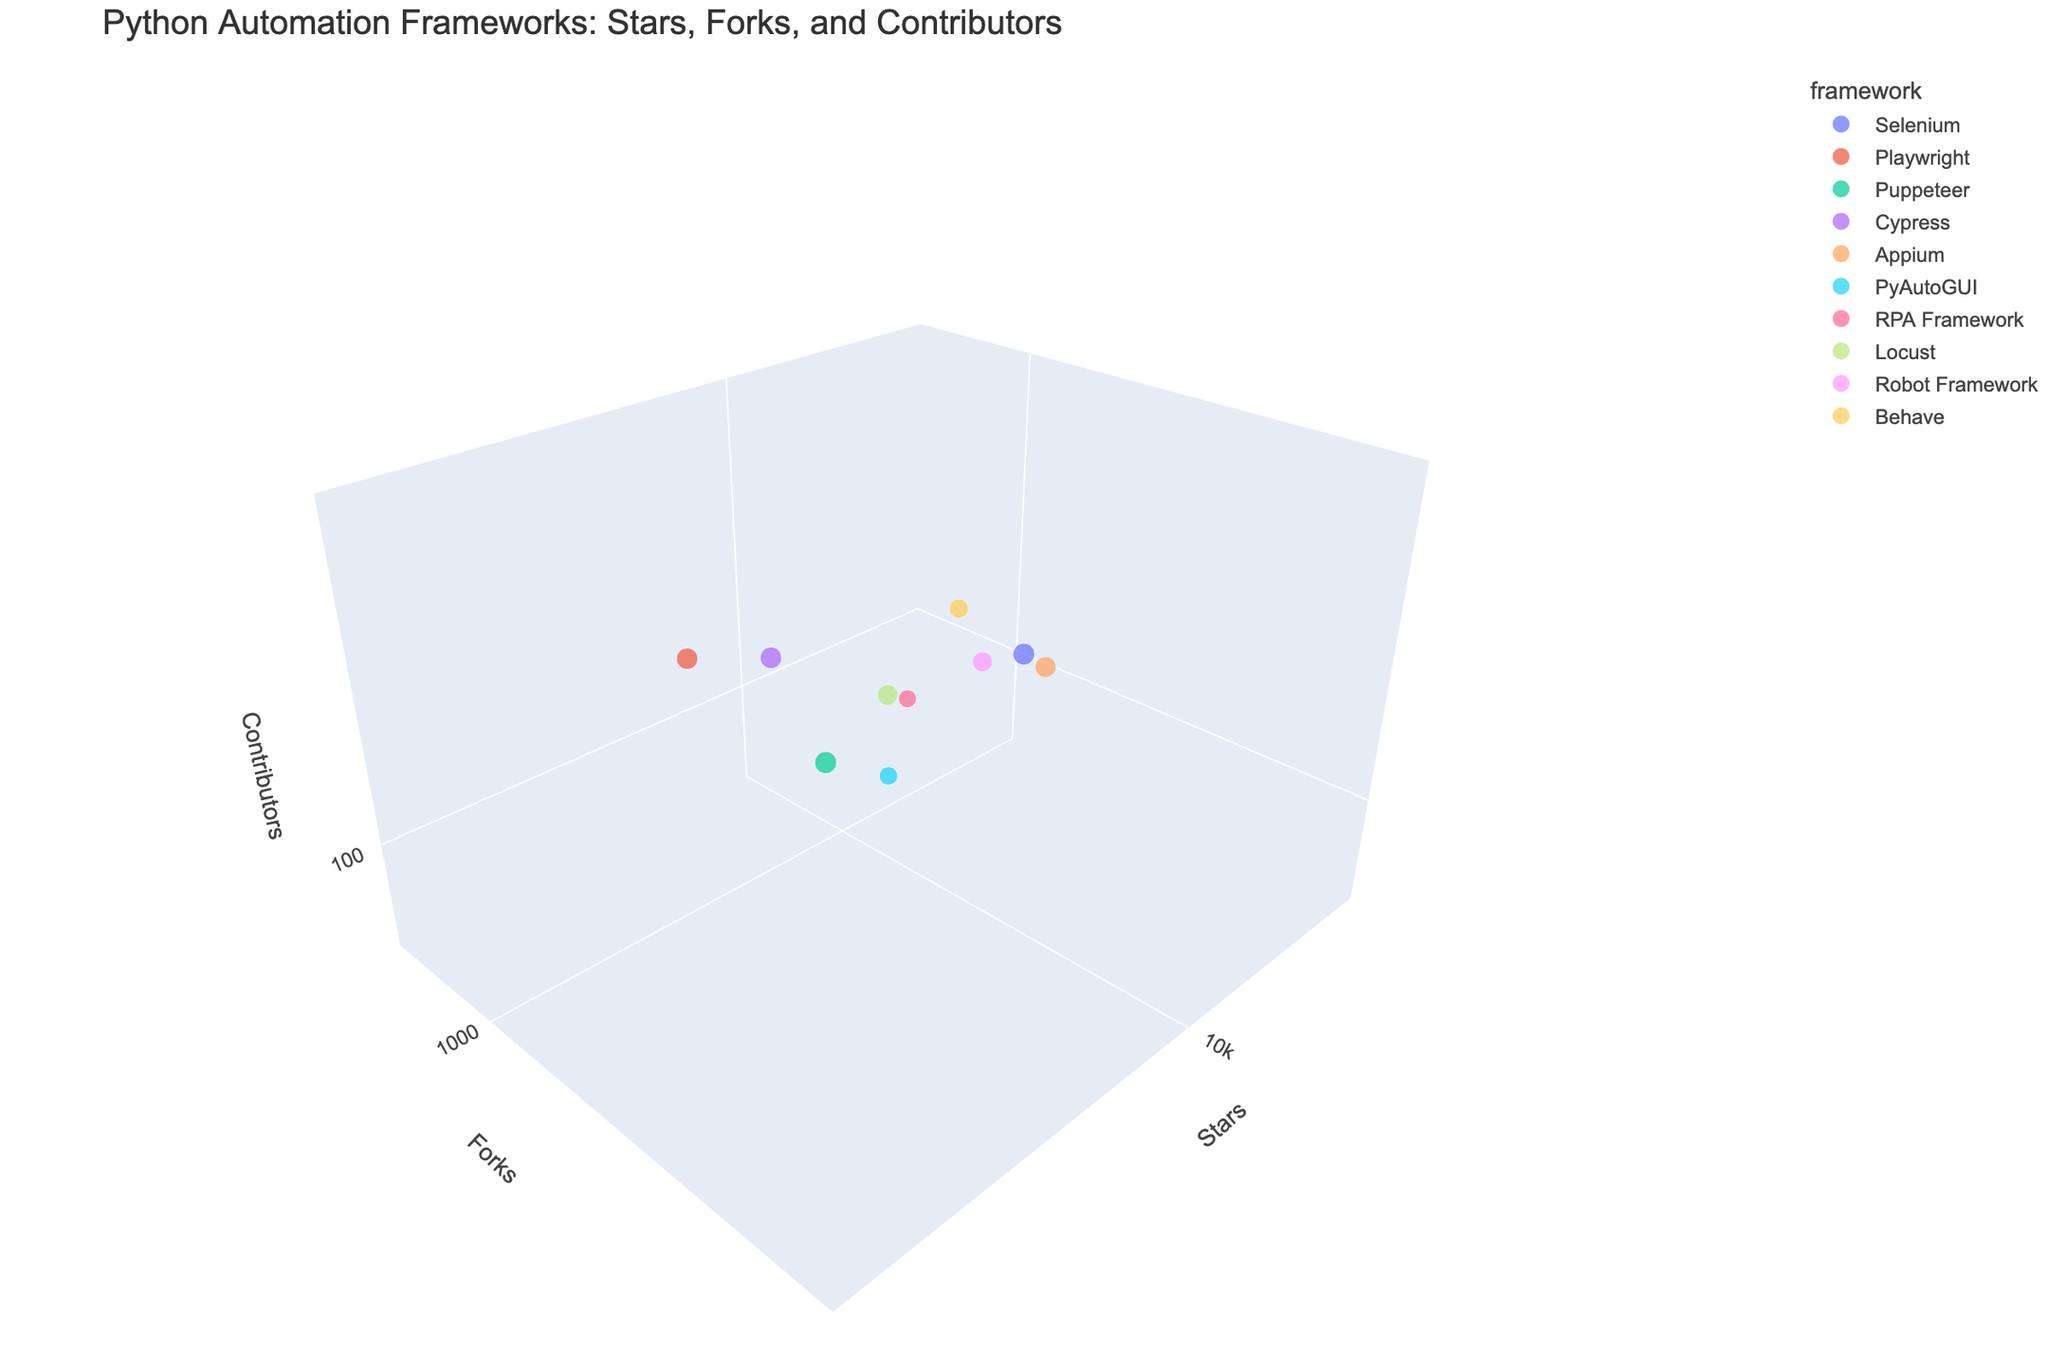Which framework has the highest number of stars? Look at the X-axis representing stars and find the bubble farthest to the right. Puppeteer is the framework with the highest stars.
Answer: Puppeteer Which framework has the lowest number of contributors? Look at the Z-axis representing contributors and find the bubble closest to the bottom. RPA Framework has the lowest number of contributors.
Answer: RPA Framework What is the approximate bubble size for the framework with the most forks? Find the bubble corresponding to the framework with the highest number of forks on the Y-axis. Puppeteer has the most forks with its bubble size reflecting approximately 20 * log(520).
Answer: Approximately 88 Are there any frameworks with more than 50,000 stars and more than 5,000 forks? Check for bubbles that are plotted beyond 50,000 on the X-axis and 5,000 on the Y-axis. Puppeteer is the only one meeting these criteria.
Answer: Yes, Puppeteer Which framework has more forks: Selenium or Cypress? Compare the Y-axis positions of the bubbles labeled Selenium and Cypress. Selenium with 6,800 forks has more than Cypress with 3,200 forks.
Answer: Selenium What is the total number of contributors for PyAutoGUI and Behave combined? Sum the contributors for PyAutoGUI (80) and Behave (120).
Answer: 200 How do the stars of Playwright compare to Appium? Compare the X-axis positions of the bubbles for Playwright and Appium. Playwright, with 48,000 stars, has significantly more stars than Appium, which has 15,000 stars.
Answer: Playwright has more Which framework is closest to having an equal number of stars and forks? Identify the bubble where the X-axis (stars) and Y-axis (forks) values are closest. Locust with 20,000 stars and 2,800 forks appears to have the closest values.
Answer: Locust What is the average number of contributors for Selenium, Playwright, and Cypress? Sum the contributors for Selenium (450), Playwright (380), and Cypress (410), then divide by 3. (450 + 380 + 410) / 3 = 1240 / 3 = 413.33
Answer: 413.33 